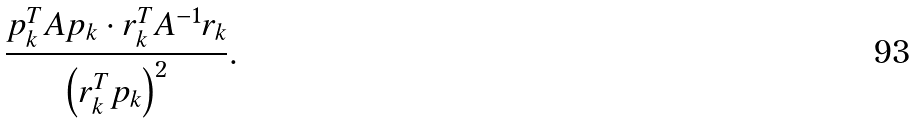Convert formula to latex. <formula><loc_0><loc_0><loc_500><loc_500>\frac { p _ { k } ^ { T } A p _ { k } \cdot r _ { k } ^ { T } A ^ { - 1 } r _ { k } } { \left ( r _ { k } ^ { T } p _ { k } \right ) ^ { 2 } } .</formula> 